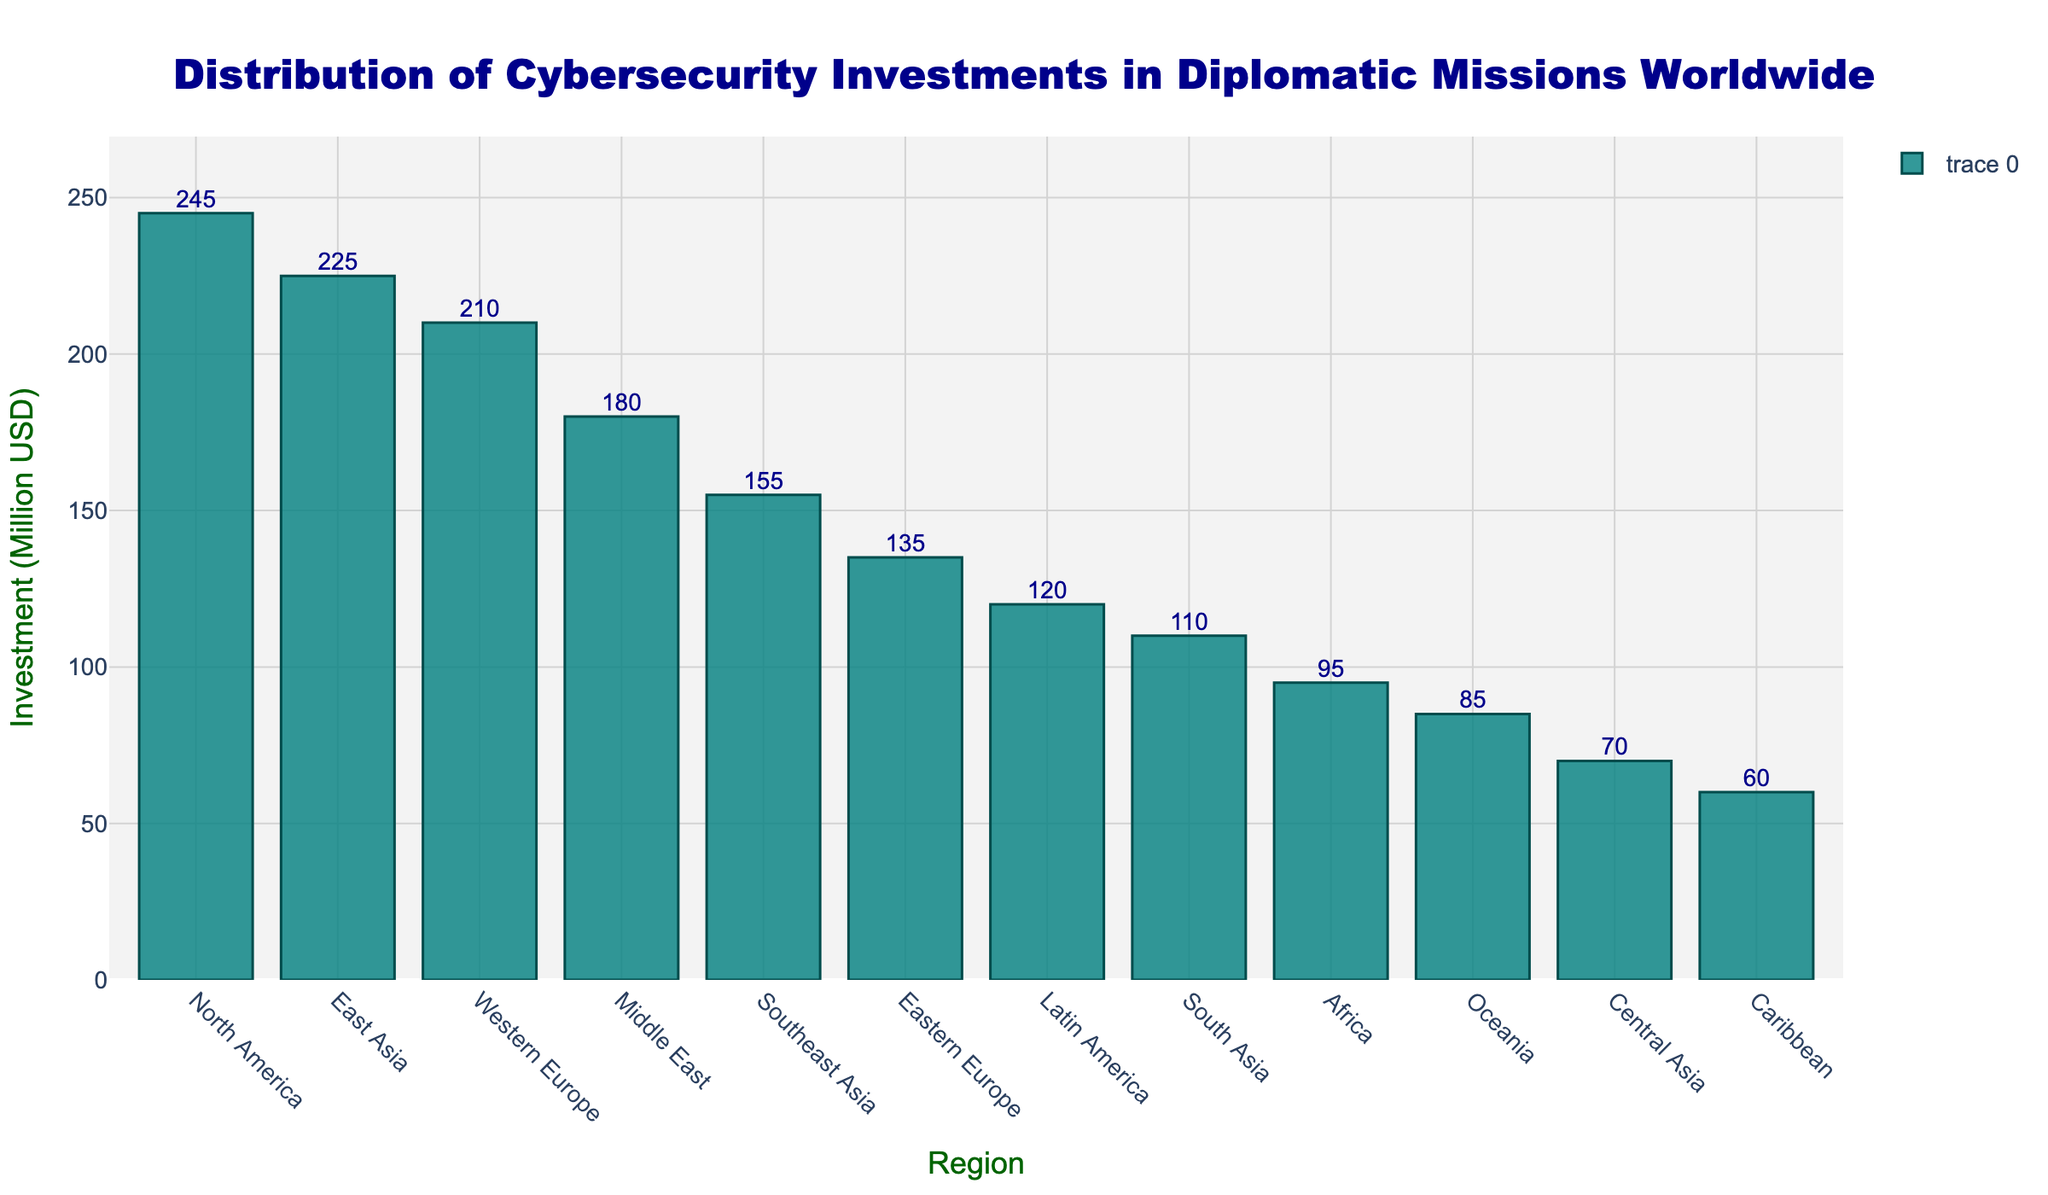Which region has the highest cybersecurity investment? The bar chart shows the height of the bars representing the investment values. The highest bar corresponds to North America.
Answer: North America Which region has the lowest cybersecurity investment? The bar chart shows the height of the bars representing the investment values. The shortest bar corresponds to the Caribbean.
Answer: Caribbean How much is the difference in cybersecurity investment between North America and Western Europe? North America's investment is 245 million USD, and Western Europe's investment is 210 million USD. The difference is 245 - 210 = 35 million USD.
Answer: 35 million USD Which regions have more than 200 million USD cybersecurity investment? By looking at the height of the bars, we can see that North America, East Asia, and Western Europe have investments exceeding 200 million USD.
Answer: North America, East Asia, Western Europe What is the average cybersecurity investment of the top three investing regions? The top three regions are North America (245 million USD), East Asia (225 million USD), and Western Europe (210 million USD). The average is (245 + 225 + 210) / 3 = 680 / 3 = 226.67 million USD.
Answer: 226.67 million USD Order the regions in descending order of their cybersecurity investment. The bars can be sorted to list the regions from the highest to the lowest bar height: North America, East Asia, Western Europe, Middle East, Southeast Asia, Eastern Europe, South Asia, Latin America, Africa, Oceania, Central Asia, Caribbean.
Answer: North America, East Asia, Western Europe, Middle East, Southeast Asia, Eastern Europe, South Asia, Latin America, Africa, Oceania, Central Asia, Caribbean What is the total cybersecurity investment in all regions combined? Sum all the values: 245 + 210 + 135 + 180 + 225 + 155 + 110 + 95 + 120 + 85 + 70 + 60 = 1690 million USD.
Answer: 1690 million USD By how much does the cybersecurity investment in East Asia exceed that in Southeast Asia? East Asia's investment is 225 million USD and Southeast Asia's is 155 million USD. The difference is 225 - 155 = 70 million USD.
Answer: 70 million USD What is the combined cybersecurity investment for all Asian regions (East Asia, Southeast Asia, South Asia, Central Asia)? Sum the values for the Asian regions: 225 (East Asia) + 155 (Southeast Asia) + 110 (South Asia) + 70 (Central Asia) = 560 million USD.
Answer: 560 million USD 